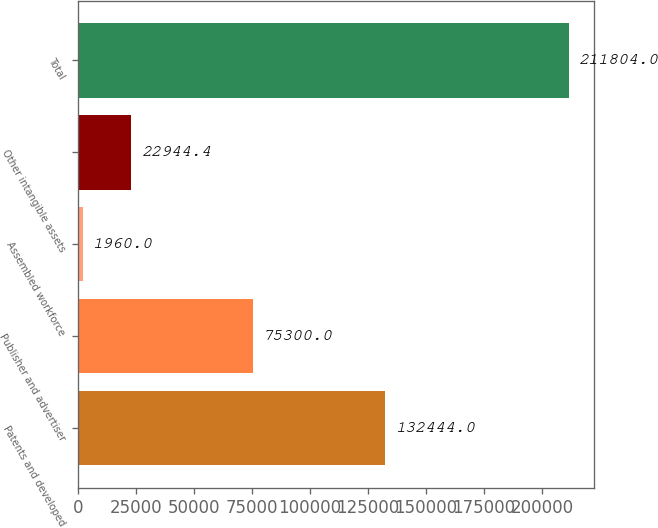<chart> <loc_0><loc_0><loc_500><loc_500><bar_chart><fcel>Patents and developed<fcel>Publisher and advertiser<fcel>Assembled workforce<fcel>Other intangible assets<fcel>Total<nl><fcel>132444<fcel>75300<fcel>1960<fcel>22944.4<fcel>211804<nl></chart> 